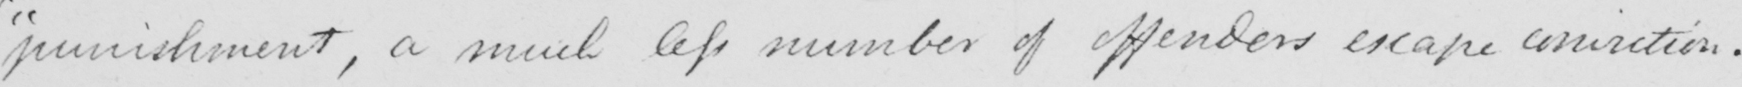Please transcribe the handwritten text in this image. " punishment , a much less number of offenders escape conviction . 